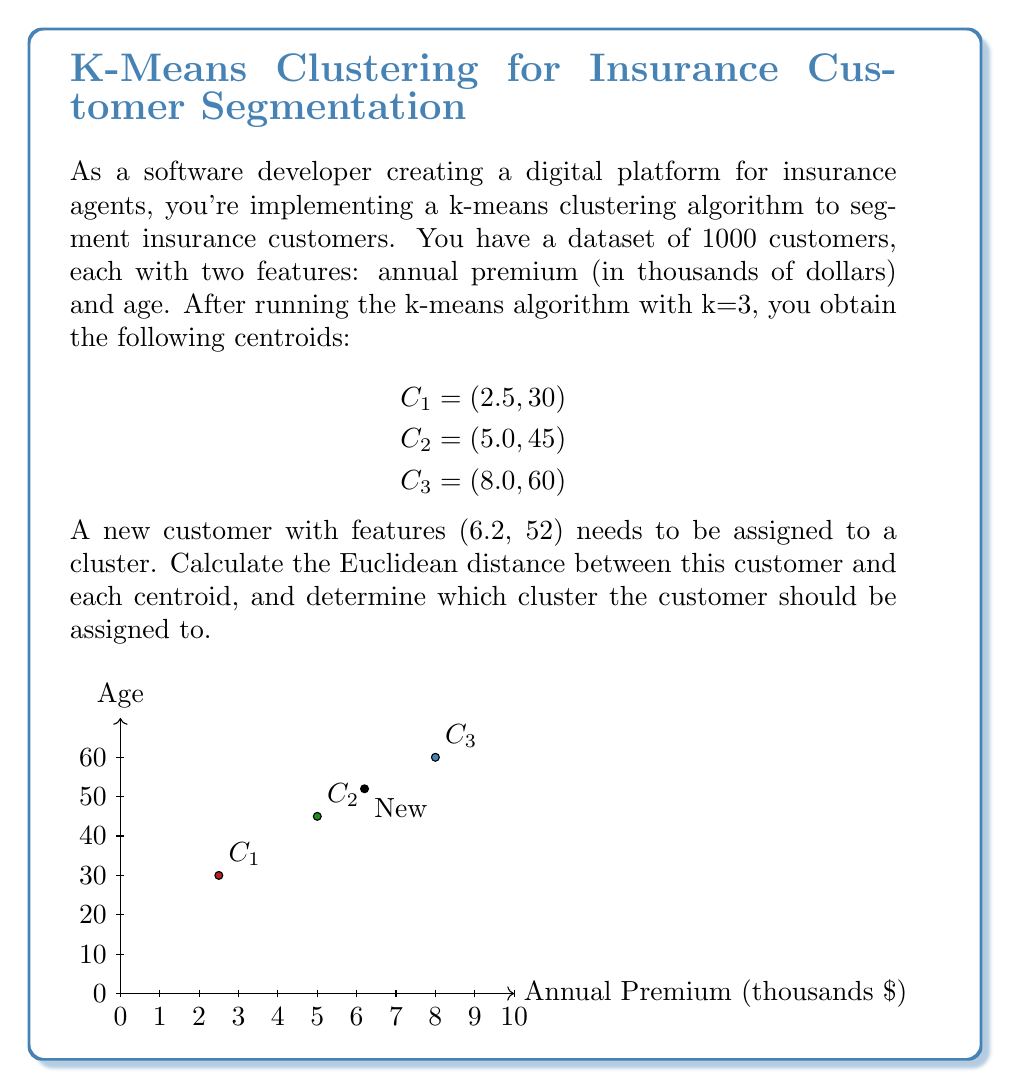Help me with this question. To solve this problem, we need to calculate the Euclidean distance between the new customer and each centroid, then assign the customer to the cluster with the smallest distance.

The Euclidean distance in 2D space is given by the formula:

$$d = \sqrt{(x_2 - x_1)^2 + (y_2 - y_1)^2}$$

Let's calculate the distance to each centroid:

1. Distance to C1 (2.5, 30):
   $$d_1 = \sqrt{(6.2 - 2.5)^2 + (52 - 30)^2} = \sqrt{3.7^2 + 22^2} = \sqrt{13.69 + 484} = \sqrt{497.69} \approx 22.31$$

2. Distance to C2 (5.0, 45):
   $$d_2 = \sqrt{(6.2 - 5.0)^2 + (52 - 45)^2} = \sqrt{1.2^2 + 7^2} = \sqrt{1.44 + 49} = \sqrt{50.44} \approx 7.10$$

3. Distance to C3 (8.0, 60):
   $$d_3 = \sqrt{(6.2 - 8.0)^2 + (52 - 60)^2} = \sqrt{(-1.8)^2 + (-8)^2} = \sqrt{3.24 + 64} = \sqrt{67.24} \approx 8.20$$

The smallest distance is $d_2 \approx 7.10$, which corresponds to centroid C2.
Answer: Cluster 2 (C2) 